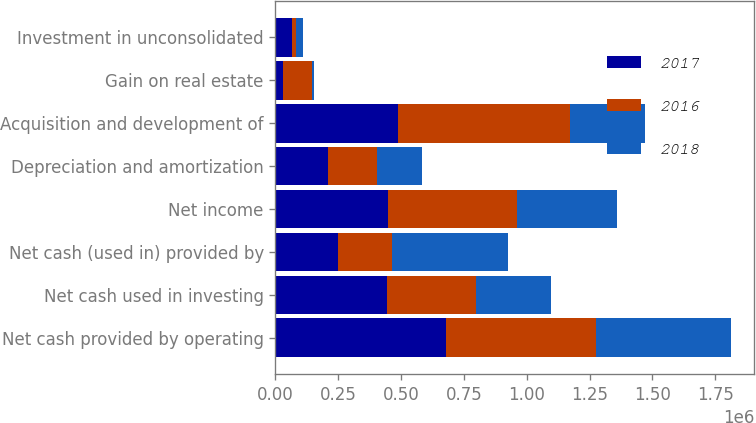Convert chart to OTSL. <chart><loc_0><loc_0><loc_500><loc_500><stacked_bar_chart><ecel><fcel>Net cash provided by operating<fcel>Net cash used in investing<fcel>Net cash (used in) provided by<fcel>Net income<fcel>Depreciation and amortization<fcel>Acquisition and development of<fcel>Gain on real estate<fcel>Investment in unconsolidated<nl><fcel>2017<fcel>677795<fcel>443898<fcel>247251<fcel>447080<fcel>209050<fcel>487065<fcel>30807<fcel>65500<nl><fcel>2016<fcel>597375<fcel>353079<fcel>215994<fcel>514222<fcel>193296<fcel>684931<fcel>112789<fcel>17944<nl><fcel>2018<fcel>539263<fcel>300165<fcel>460831<fcel>397089<fcel>182560<fcel>300165<fcel>8465<fcel>28241<nl></chart> 